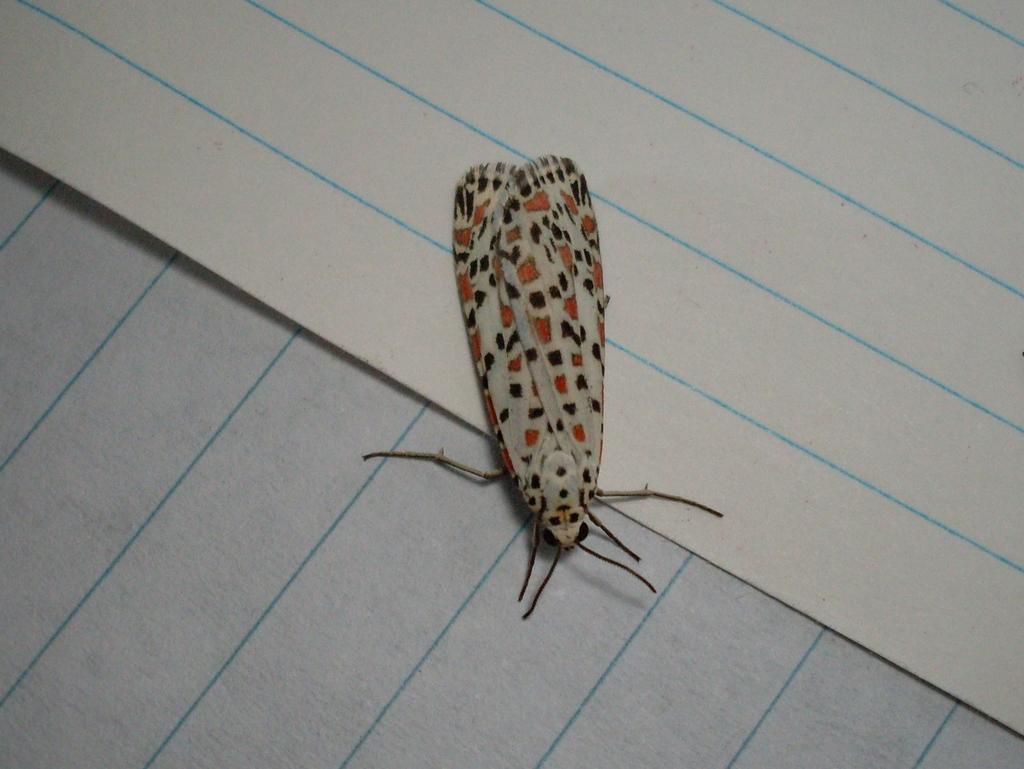Can you describe this image briefly? In this image there are two papers. In the middle of the image there is a fly on the papers. 